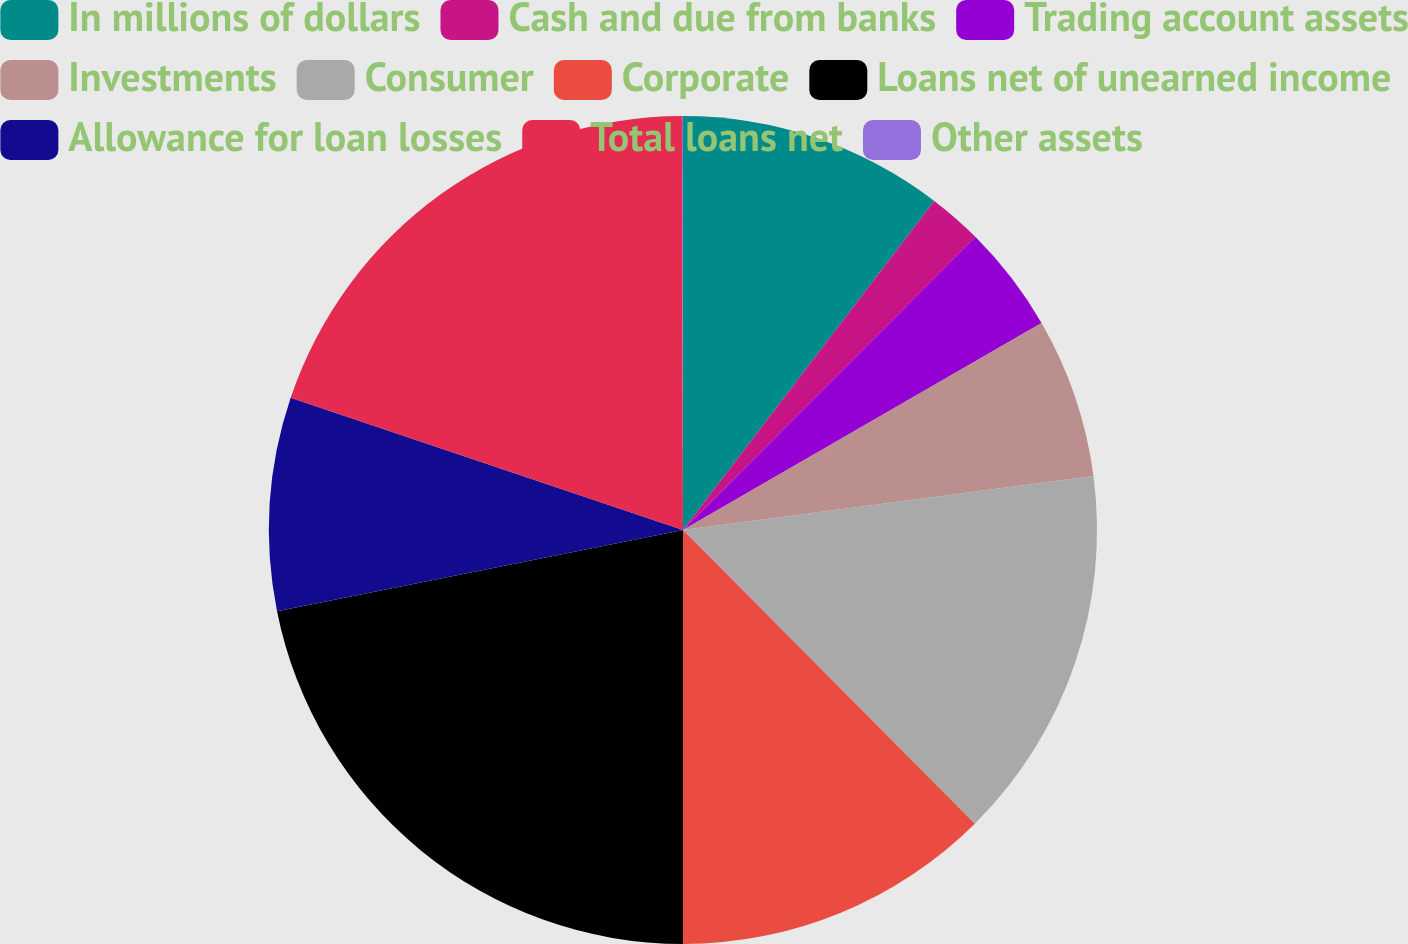<chart> <loc_0><loc_0><loc_500><loc_500><pie_chart><fcel>In millions of dollars<fcel>Cash and due from banks<fcel>Trading account assets<fcel>Investments<fcel>Consumer<fcel>Corporate<fcel>Loans net of unearned income<fcel>Allowance for loan losses<fcel>Total loans net<fcel>Other assets<nl><fcel>10.38%<fcel>2.11%<fcel>4.18%<fcel>6.25%<fcel>14.63%<fcel>12.45%<fcel>21.86%<fcel>8.31%<fcel>19.79%<fcel>0.04%<nl></chart> 